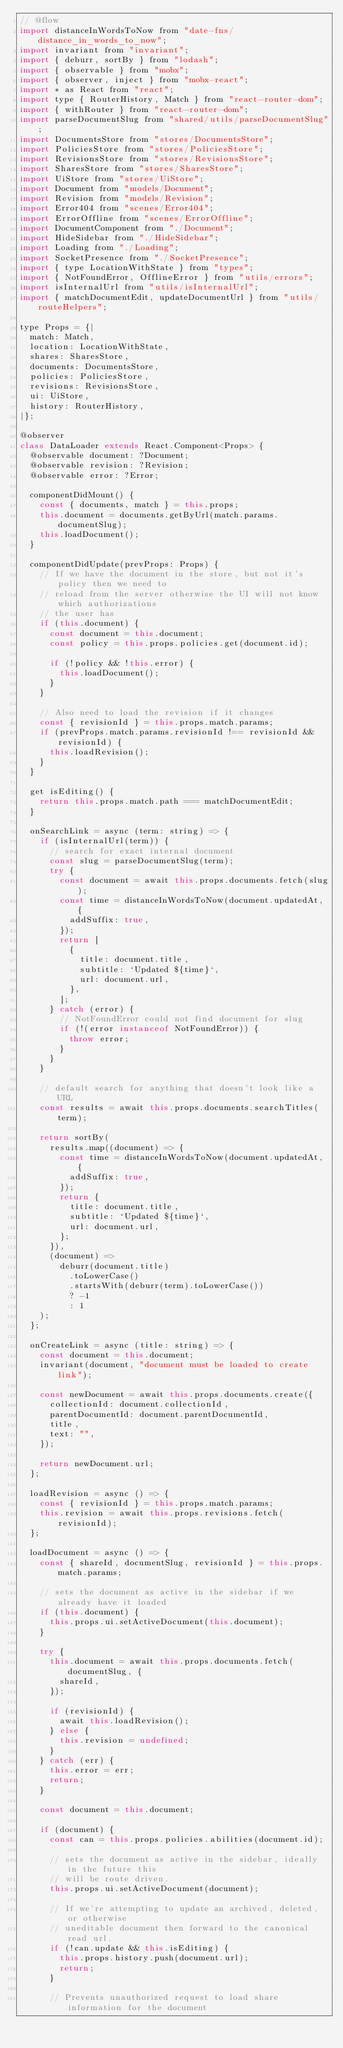Convert code to text. <code><loc_0><loc_0><loc_500><loc_500><_JavaScript_>// @flow
import distanceInWordsToNow from "date-fns/distance_in_words_to_now";
import invariant from "invariant";
import { deburr, sortBy } from "lodash";
import { observable } from "mobx";
import { observer, inject } from "mobx-react";
import * as React from "react";
import type { RouterHistory, Match } from "react-router-dom";
import { withRouter } from "react-router-dom";
import parseDocumentSlug from "shared/utils/parseDocumentSlug";
import DocumentsStore from "stores/DocumentsStore";
import PoliciesStore from "stores/PoliciesStore";
import RevisionsStore from "stores/RevisionsStore";
import SharesStore from "stores/SharesStore";
import UiStore from "stores/UiStore";
import Document from "models/Document";
import Revision from "models/Revision";
import Error404 from "scenes/Error404";
import ErrorOffline from "scenes/ErrorOffline";
import DocumentComponent from "./Document";
import HideSidebar from "./HideSidebar";
import Loading from "./Loading";
import SocketPresence from "./SocketPresence";
import { type LocationWithState } from "types";
import { NotFoundError, OfflineError } from "utils/errors";
import isInternalUrl from "utils/isInternalUrl";
import { matchDocumentEdit, updateDocumentUrl } from "utils/routeHelpers";

type Props = {|
  match: Match,
  location: LocationWithState,
  shares: SharesStore,
  documents: DocumentsStore,
  policies: PoliciesStore,
  revisions: RevisionsStore,
  ui: UiStore,
  history: RouterHistory,
|};

@observer
class DataLoader extends React.Component<Props> {
  @observable document: ?Document;
  @observable revision: ?Revision;
  @observable error: ?Error;

  componentDidMount() {
    const { documents, match } = this.props;
    this.document = documents.getByUrl(match.params.documentSlug);
    this.loadDocument();
  }

  componentDidUpdate(prevProps: Props) {
    // If we have the document in the store, but not it's policy then we need to
    // reload from the server otherwise the UI will not know which authorizations
    // the user has
    if (this.document) {
      const document = this.document;
      const policy = this.props.policies.get(document.id);

      if (!policy && !this.error) {
        this.loadDocument();
      }
    }

    // Also need to load the revision if it changes
    const { revisionId } = this.props.match.params;
    if (prevProps.match.params.revisionId !== revisionId && revisionId) {
      this.loadRevision();
    }
  }

  get isEditing() {
    return this.props.match.path === matchDocumentEdit;
  }

  onSearchLink = async (term: string) => {
    if (isInternalUrl(term)) {
      // search for exact internal document
      const slug = parseDocumentSlug(term);
      try {
        const document = await this.props.documents.fetch(slug);
        const time = distanceInWordsToNow(document.updatedAt, {
          addSuffix: true,
        });
        return [
          {
            title: document.title,
            subtitle: `Updated ${time}`,
            url: document.url,
          },
        ];
      } catch (error) {
        // NotFoundError could not find document for slug
        if (!(error instanceof NotFoundError)) {
          throw error;
        }
      }
    }

    // default search for anything that doesn't look like a URL
    const results = await this.props.documents.searchTitles(term);

    return sortBy(
      results.map((document) => {
        const time = distanceInWordsToNow(document.updatedAt, {
          addSuffix: true,
        });
        return {
          title: document.title,
          subtitle: `Updated ${time}`,
          url: document.url,
        };
      }),
      (document) =>
        deburr(document.title)
          .toLowerCase()
          .startsWith(deburr(term).toLowerCase())
          ? -1
          : 1
    );
  };

  onCreateLink = async (title: string) => {
    const document = this.document;
    invariant(document, "document must be loaded to create link");

    const newDocument = await this.props.documents.create({
      collectionId: document.collectionId,
      parentDocumentId: document.parentDocumentId,
      title,
      text: "",
    });

    return newDocument.url;
  };

  loadRevision = async () => {
    const { revisionId } = this.props.match.params;
    this.revision = await this.props.revisions.fetch(revisionId);
  };

  loadDocument = async () => {
    const { shareId, documentSlug, revisionId } = this.props.match.params;

    // sets the document as active in the sidebar if we already have it loaded
    if (this.document) {
      this.props.ui.setActiveDocument(this.document);
    }

    try {
      this.document = await this.props.documents.fetch(documentSlug, {
        shareId,
      });

      if (revisionId) {
        await this.loadRevision();
      } else {
        this.revision = undefined;
      }
    } catch (err) {
      this.error = err;
      return;
    }

    const document = this.document;

    if (document) {
      const can = this.props.policies.abilities(document.id);

      // sets the document as active in the sidebar, ideally in the future this
      // will be route driven.
      this.props.ui.setActiveDocument(document);

      // If we're attempting to update an archived, deleted, or otherwise
      // uneditable document then forward to the canonical read url.
      if (!can.update && this.isEditing) {
        this.props.history.push(document.url);
        return;
      }

      // Prevents unauthorized request to load share information for the document</code> 